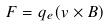Convert formula to latex. <formula><loc_0><loc_0><loc_500><loc_500>F = q _ { e } ( v \times B )</formula> 